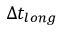<formula> <loc_0><loc_0><loc_500><loc_500>\Delta t _ { l o n g }</formula> 